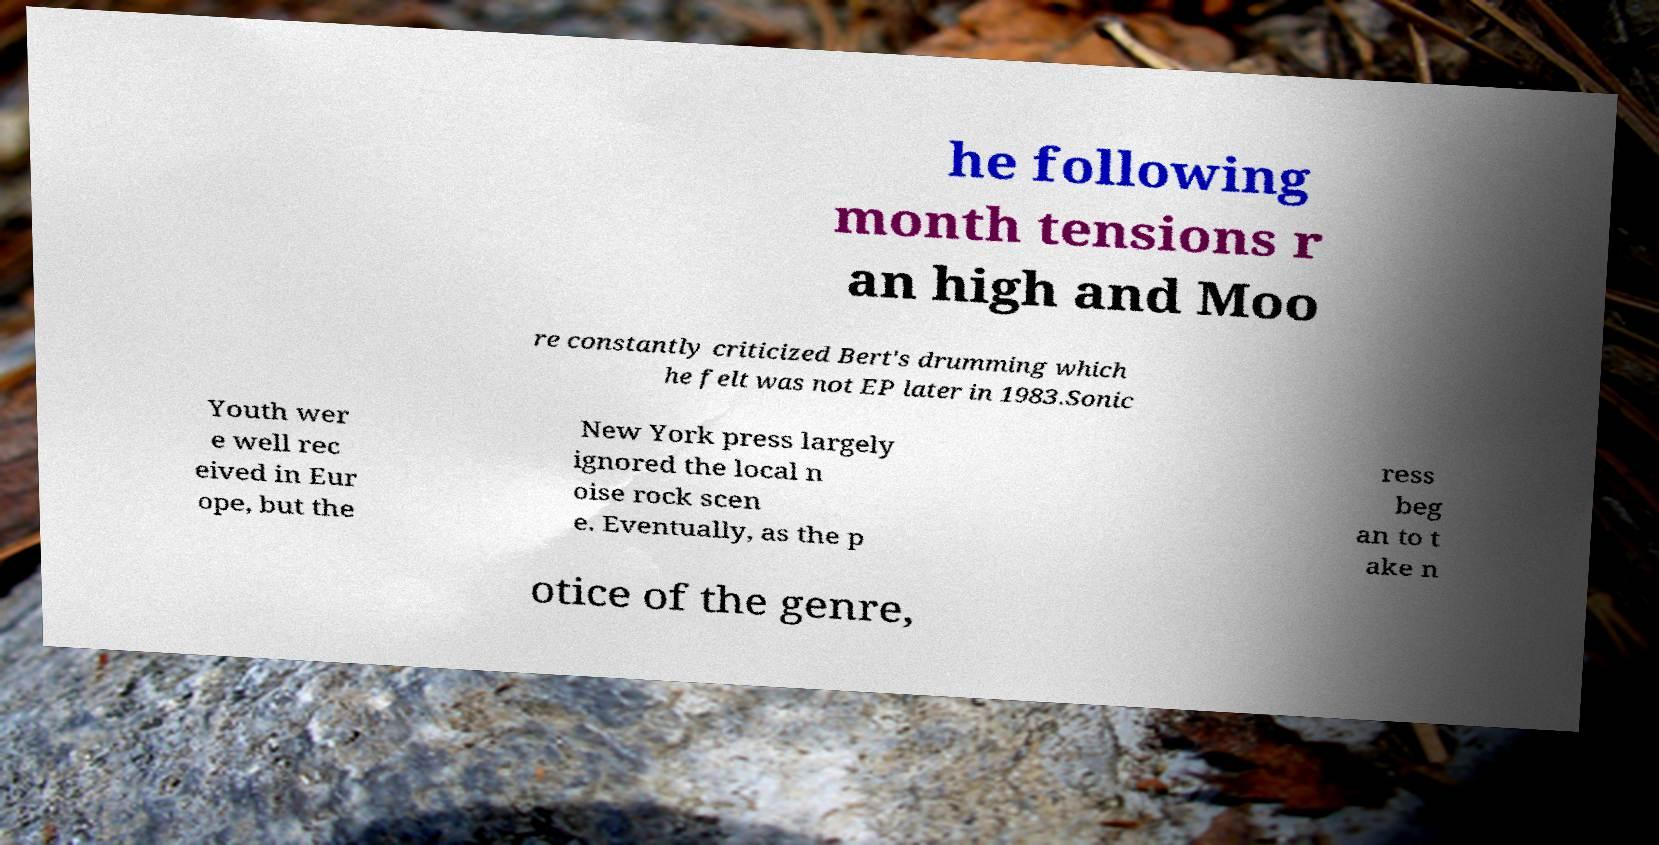For documentation purposes, I need the text within this image transcribed. Could you provide that? he following month tensions r an high and Moo re constantly criticized Bert's drumming which he felt was not EP later in 1983.Sonic Youth wer e well rec eived in Eur ope, but the New York press largely ignored the local n oise rock scen e. Eventually, as the p ress beg an to t ake n otice of the genre, 